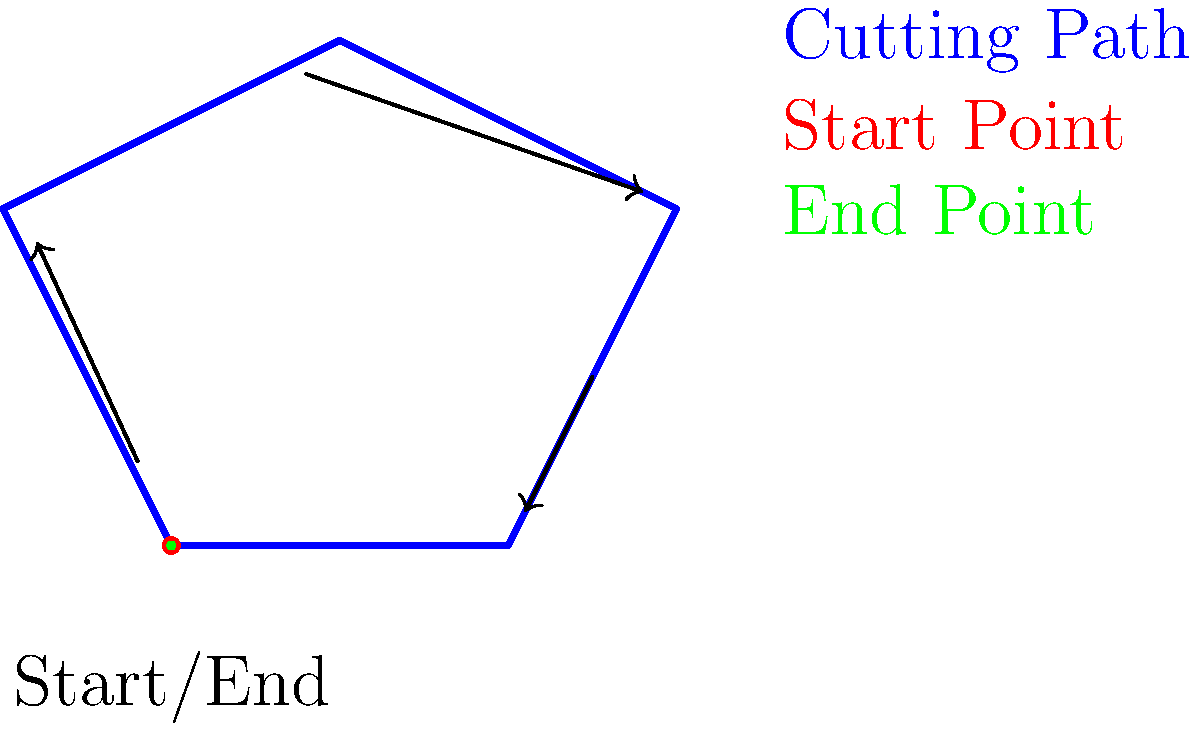In the SheetCam visual output shown above, which point represents both the start and end of the cutting path? To identify the start and end points of a cutting path in SheetCam's visual output, follow these steps:

1. Observe the blue line, which represents the cutting path.
2. Look for a point that is marked differently from the rest of the path.
3. In this diagram, there is a point at $(0,0)$ that is marked with both red and green colors.
4. The red color typically indicates the start point of a cutting path.
5. The green color typically indicates the end point of a cutting path.
6. When the start and end points are the same, it means the cutting path forms a closed loop.
7. The arrows along the path show the direction of the cut, starting and ending at the same point.
8. The label "Start/End" confirms that this point serves as both the beginning and end of the cutting path.

Therefore, the point at $(0,0)$, marked with both red and green colors, represents both the start and end of the cutting path in this SheetCam visual output.
Answer: The point at $(0,0)$ 